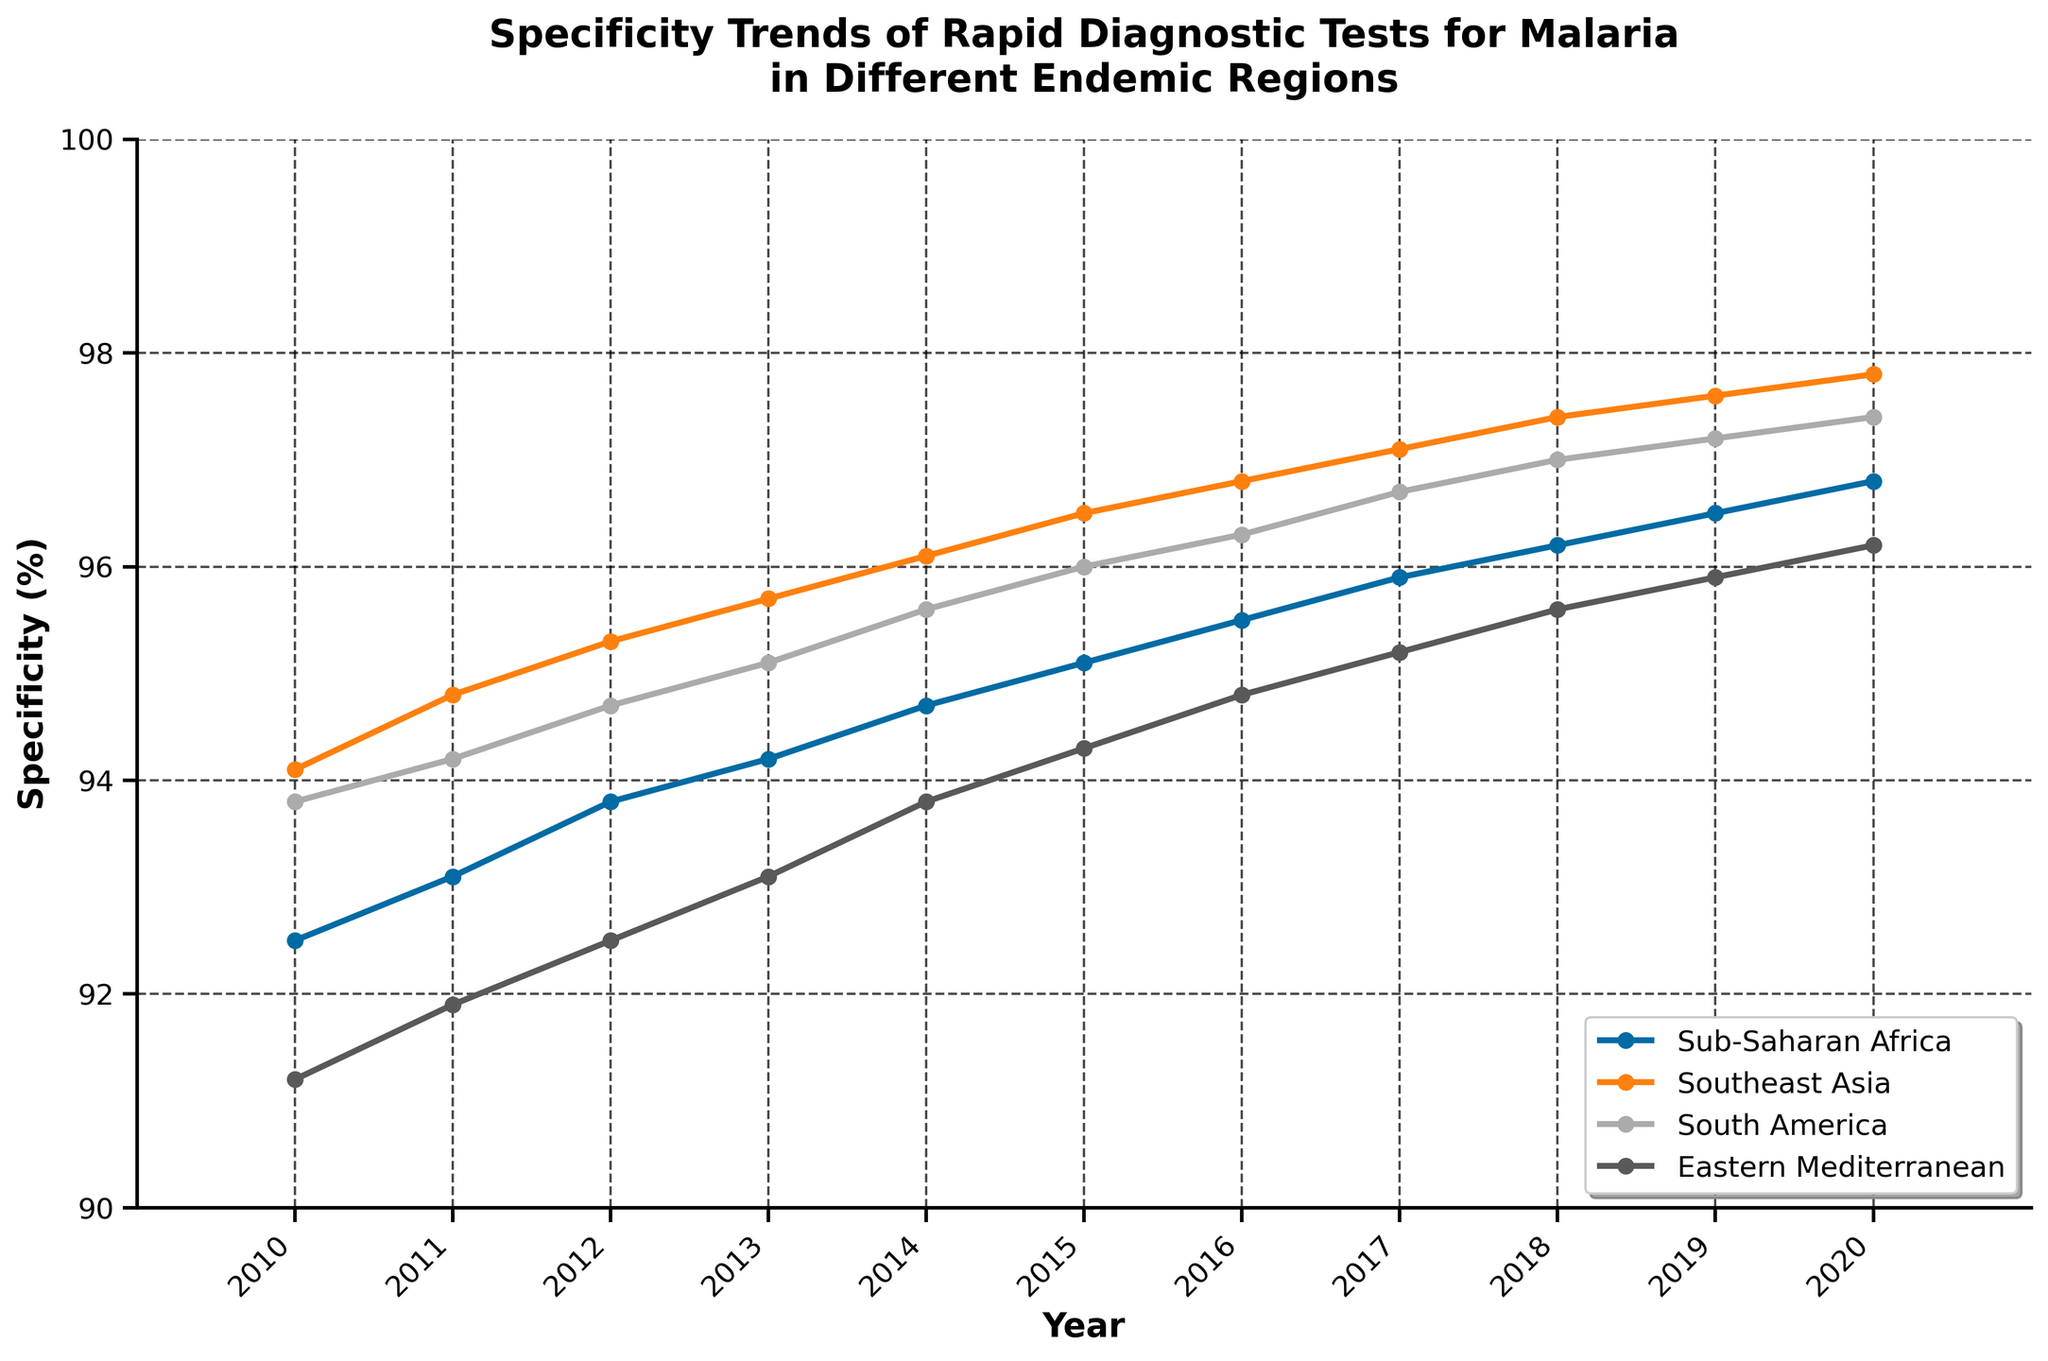What is the overall trend in the specificity for rapid diagnostic tests for malaria in Sub-Saharan Africa from 2010 to 2020? The plot shows a line graph where each point represents the specificity in a given year. For Sub-Saharan Africa, the data points indicate that specificity increases every year. We start from approximately 92.5% in 2010 and reach around 96.8% in 2020.
Answer: Increasing trend In which year did Southeast Asia surpass a 97% specificity for rapid diagnostic tests for malaria? By observing the line corresponding to Southeast Asia, we can see that 2017 is the first year where specificity is above 97%, shown by the data point at 97.1%.
Answer: 2017 Which endemic region had the highest specificity in 2019? By comparing the data points for all regions in 2019, we see that Southeast Asia has the highest specificity with a value of 97.6%.
Answer: Southeast Asia How did the specificity of rapid diagnostic tests for malaria in South America change between 2014 and 2018? Firstly, identify the data points for South America in 2014 and 2018, which are 95.6% and 97.0%, respectively. Calculate the difference: 97.0 - 95.6 = 1.4%. Thus, specificity increased by 1.4 percentage points.
Answer: Increased by 1.4 percentage points What is the average specificity for Eastern Mediterranean in the last three years (2018, 2019, 2020)? The specific values for Eastern Mediterranean in 2018, 2019, and 2020 are 95.6, 95.9, and 96.2, respectively. Sum these values (95.6 + 95.9 + 96.2 = 287.7) and divide by 3 to find the average: 287.7 / 3 = 95.9.
Answer: 95.9 Which region shows the least variability in specificity over the years? Comparing the plot lines, Southeast Asia shows the least variability because its curve is the smoothest with the smallest deviations year-over-year.
Answer: Southeast Asia By how many percentage points did the specificity in Sub-Saharan Africa increase from 2010 to 2020? The specificity for Sub-Saharan Africa in 2010 is 92.5% and in 2020 is 96.8%. The increase is calculated as 96.8 - 92.5 = 4.3 percentage points.
Answer: 4.3 percentage points Which region had a specificity value of exactly 95% at any point, and in which year did that occur? By tracing the plot lines, we see that Sub-Saharan Africa had a specificity value of 95.0% in 2015.
Answer: Sub-Saharan Africa, 2015 